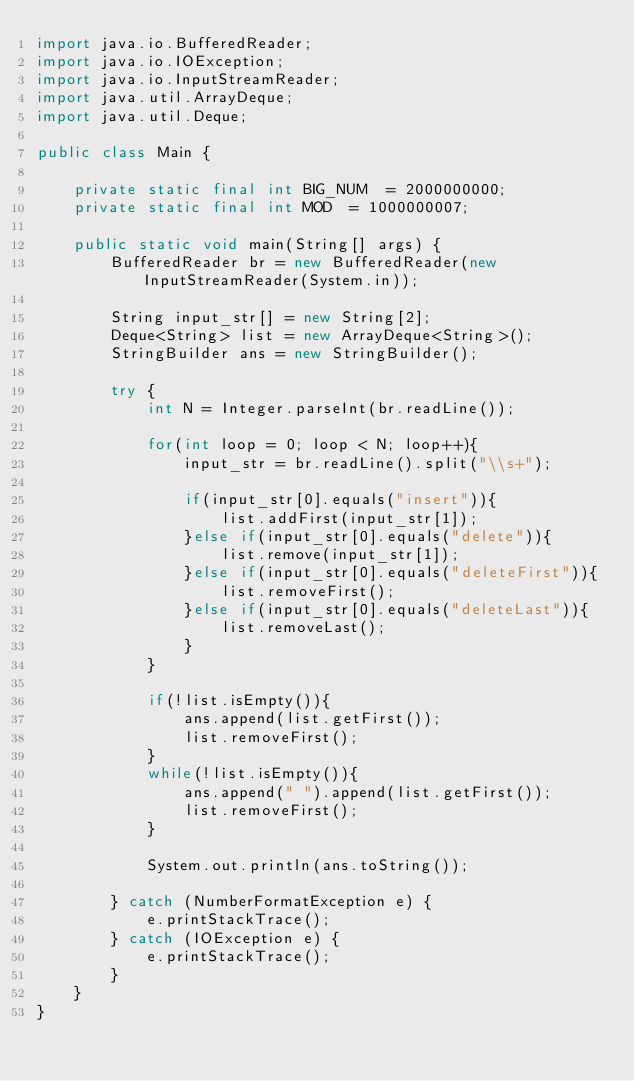Convert code to text. <code><loc_0><loc_0><loc_500><loc_500><_Java_>import java.io.BufferedReader;
import java.io.IOException;
import java.io.InputStreamReader;
import java.util.ArrayDeque;
import java.util.Deque;

public class Main {

	private static final int BIG_NUM  = 2000000000;
	private static final int MOD  = 1000000007;

	public static void main(String[] args) {
		BufferedReader br = new BufferedReader(new InputStreamReader(System.in));

		String input_str[] = new String[2];
		Deque<String> list = new ArrayDeque<String>();
		StringBuilder ans = new StringBuilder();

		try {
			int N = Integer.parseInt(br.readLine());

			for(int loop = 0; loop < N; loop++){
				input_str = br.readLine().split("\\s+");

				if(input_str[0].equals("insert")){
					list.addFirst(input_str[1]);
				}else if(input_str[0].equals("delete")){
					list.remove(input_str[1]);
				}else if(input_str[0].equals("deleteFirst")){
					list.removeFirst();
				}else if(input_str[0].equals("deleteLast")){
					list.removeLast();
				}
			}

			if(!list.isEmpty()){
				ans.append(list.getFirst());
				list.removeFirst();
			}
			while(!list.isEmpty()){
				ans.append(" ").append(list.getFirst());
				list.removeFirst();
			}

			System.out.println(ans.toString());

		} catch (NumberFormatException e) {
			e.printStackTrace();
		} catch (IOException e) {
			e.printStackTrace();
		}
	}
}


</code> 